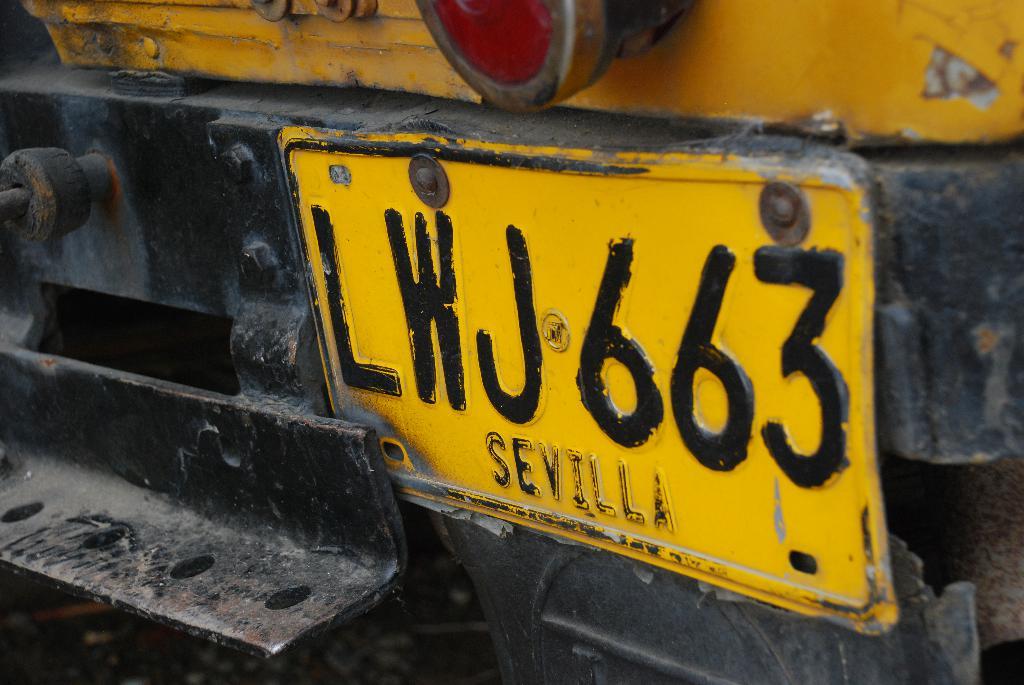Which number is used twice on the license plate?
Make the answer very short. 6. What is the county is on the license plate?
Provide a short and direct response. Sevilla. 